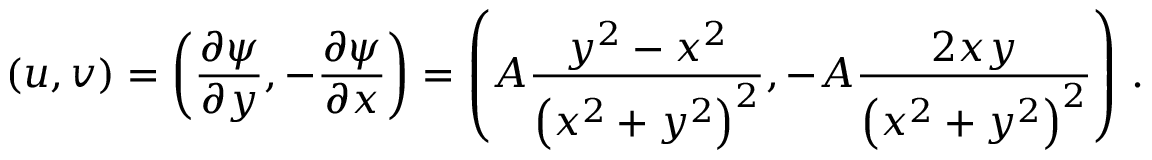<formula> <loc_0><loc_0><loc_500><loc_500>( u , v ) = \left ( { \frac { \partial \psi } { \partial y } } , - { \frac { \partial \psi } { \partial x } } \right ) = \left ( A { \frac { y ^ { 2 } - x ^ { 2 } } { \left ( x ^ { 2 } + y ^ { 2 } \right ) ^ { 2 } } } , - A { \frac { 2 x y } { \left ( x ^ { 2 } + y ^ { 2 } \right ) ^ { 2 } } } \right ) \, .</formula> 